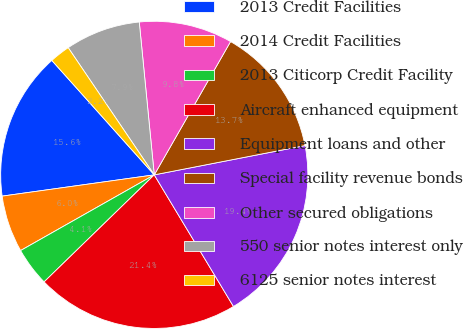Convert chart. <chart><loc_0><loc_0><loc_500><loc_500><pie_chart><fcel>2013 Credit Facilities<fcel>2014 Credit Facilities<fcel>2013 Citicorp Credit Facility<fcel>Aircraft enhanced equipment<fcel>Equipment loans and other<fcel>Special facility revenue bonds<fcel>Other secured obligations<fcel>550 senior notes interest only<fcel>6125 senior notes interest<nl><fcel>15.59%<fcel>5.99%<fcel>4.07%<fcel>21.35%<fcel>19.43%<fcel>13.67%<fcel>9.83%<fcel>7.91%<fcel>2.15%<nl></chart> 